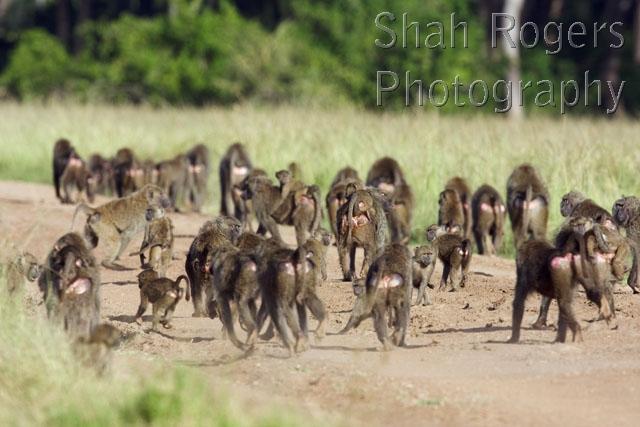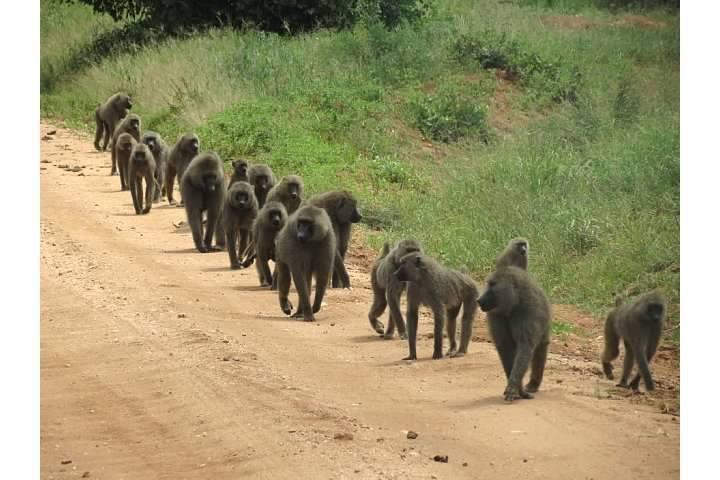The first image is the image on the left, the second image is the image on the right. For the images shown, is this caption "The right image shows a large group of animals on a road." true? Answer yes or no. Yes. The first image is the image on the left, the second image is the image on the right. Given the left and right images, does the statement "One image has no more than 7 baboons." hold true? Answer yes or no. No. 